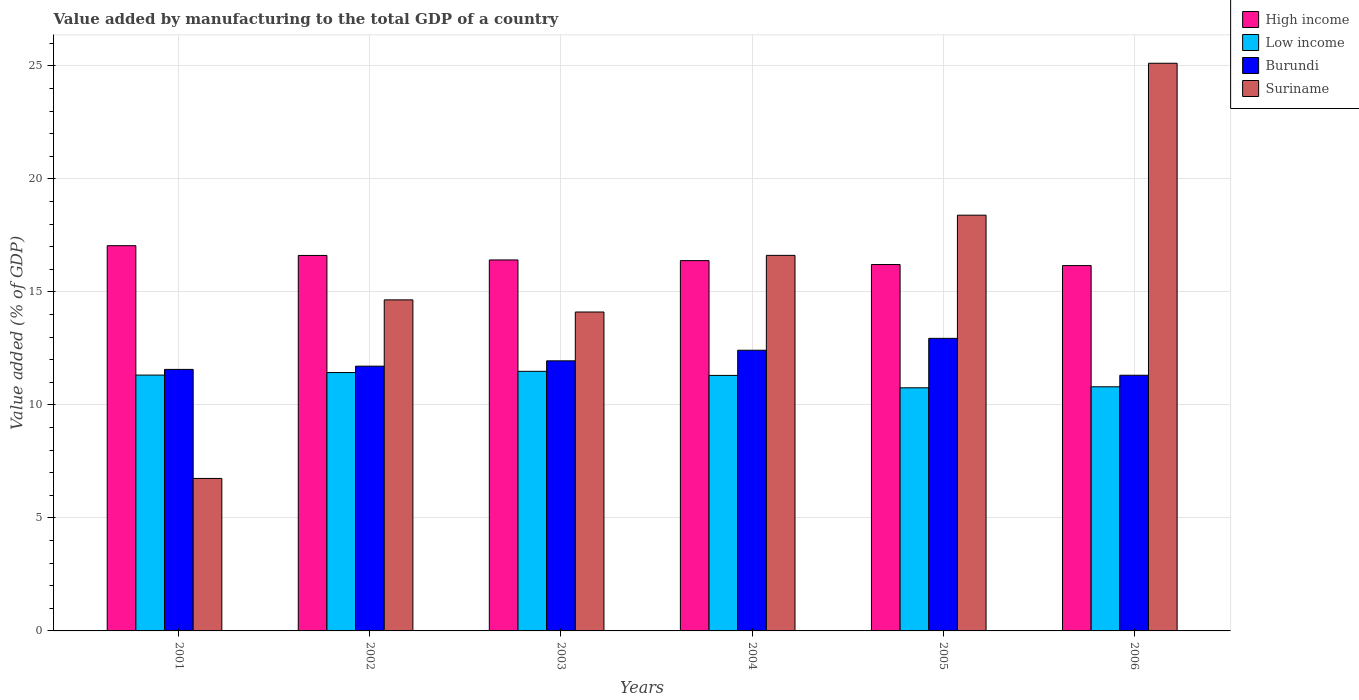Are the number of bars per tick equal to the number of legend labels?
Make the answer very short. Yes. How many bars are there on the 1st tick from the left?
Provide a succinct answer. 4. What is the label of the 5th group of bars from the left?
Provide a short and direct response. 2005. In how many cases, is the number of bars for a given year not equal to the number of legend labels?
Your response must be concise. 0. What is the value added by manufacturing to the total GDP in Suriname in 2005?
Provide a succinct answer. 18.39. Across all years, what is the maximum value added by manufacturing to the total GDP in Burundi?
Offer a terse response. 12.95. Across all years, what is the minimum value added by manufacturing to the total GDP in High income?
Provide a short and direct response. 16.16. What is the total value added by manufacturing to the total GDP in High income in the graph?
Make the answer very short. 98.83. What is the difference between the value added by manufacturing to the total GDP in High income in 2005 and that in 2006?
Make the answer very short. 0.05. What is the difference between the value added by manufacturing to the total GDP in Burundi in 2005 and the value added by manufacturing to the total GDP in Low income in 2004?
Give a very brief answer. 1.64. What is the average value added by manufacturing to the total GDP in Suriname per year?
Give a very brief answer. 15.94. In the year 2001, what is the difference between the value added by manufacturing to the total GDP in Suriname and value added by manufacturing to the total GDP in High income?
Your answer should be compact. -10.3. In how many years, is the value added by manufacturing to the total GDP in Low income greater than 14 %?
Give a very brief answer. 0. What is the ratio of the value added by manufacturing to the total GDP in High income in 2002 to that in 2004?
Offer a terse response. 1.01. What is the difference between the highest and the second highest value added by manufacturing to the total GDP in High income?
Offer a very short reply. 0.43. What is the difference between the highest and the lowest value added by manufacturing to the total GDP in Burundi?
Offer a terse response. 1.63. Is it the case that in every year, the sum of the value added by manufacturing to the total GDP in Low income and value added by manufacturing to the total GDP in Suriname is greater than the sum of value added by manufacturing to the total GDP in High income and value added by manufacturing to the total GDP in Burundi?
Your response must be concise. No. What does the 3rd bar from the left in 2002 represents?
Make the answer very short. Burundi. What does the 2nd bar from the right in 2006 represents?
Your response must be concise. Burundi. Is it the case that in every year, the sum of the value added by manufacturing to the total GDP in High income and value added by manufacturing to the total GDP in Suriname is greater than the value added by manufacturing to the total GDP in Low income?
Your response must be concise. Yes. How many years are there in the graph?
Give a very brief answer. 6. What is the difference between two consecutive major ticks on the Y-axis?
Provide a short and direct response. 5. Does the graph contain any zero values?
Give a very brief answer. No. How many legend labels are there?
Make the answer very short. 4. What is the title of the graph?
Offer a terse response. Value added by manufacturing to the total GDP of a country. Does "Channel Islands" appear as one of the legend labels in the graph?
Give a very brief answer. No. What is the label or title of the X-axis?
Your answer should be compact. Years. What is the label or title of the Y-axis?
Your answer should be compact. Value added (% of GDP). What is the Value added (% of GDP) in High income in 2001?
Ensure brevity in your answer.  17.05. What is the Value added (% of GDP) in Low income in 2001?
Your response must be concise. 11.32. What is the Value added (% of GDP) of Burundi in 2001?
Offer a terse response. 11.57. What is the Value added (% of GDP) of Suriname in 2001?
Ensure brevity in your answer.  6.75. What is the Value added (% of GDP) in High income in 2002?
Give a very brief answer. 16.61. What is the Value added (% of GDP) of Low income in 2002?
Offer a very short reply. 11.43. What is the Value added (% of GDP) of Burundi in 2002?
Offer a very short reply. 11.71. What is the Value added (% of GDP) of Suriname in 2002?
Your answer should be very brief. 14.65. What is the Value added (% of GDP) in High income in 2003?
Make the answer very short. 16.41. What is the Value added (% of GDP) of Low income in 2003?
Make the answer very short. 11.49. What is the Value added (% of GDP) in Burundi in 2003?
Make the answer very short. 11.95. What is the Value added (% of GDP) of Suriname in 2003?
Keep it short and to the point. 14.11. What is the Value added (% of GDP) in High income in 2004?
Keep it short and to the point. 16.38. What is the Value added (% of GDP) of Low income in 2004?
Your answer should be very brief. 11.3. What is the Value added (% of GDP) of Burundi in 2004?
Your answer should be very brief. 12.42. What is the Value added (% of GDP) of Suriname in 2004?
Provide a succinct answer. 16.62. What is the Value added (% of GDP) of High income in 2005?
Provide a succinct answer. 16.21. What is the Value added (% of GDP) of Low income in 2005?
Your response must be concise. 10.76. What is the Value added (% of GDP) in Burundi in 2005?
Your response must be concise. 12.95. What is the Value added (% of GDP) in Suriname in 2005?
Offer a terse response. 18.39. What is the Value added (% of GDP) of High income in 2006?
Provide a short and direct response. 16.16. What is the Value added (% of GDP) of Low income in 2006?
Give a very brief answer. 10.8. What is the Value added (% of GDP) in Burundi in 2006?
Keep it short and to the point. 11.31. What is the Value added (% of GDP) of Suriname in 2006?
Your response must be concise. 25.12. Across all years, what is the maximum Value added (% of GDP) in High income?
Offer a very short reply. 17.05. Across all years, what is the maximum Value added (% of GDP) of Low income?
Your answer should be compact. 11.49. Across all years, what is the maximum Value added (% of GDP) of Burundi?
Offer a very short reply. 12.95. Across all years, what is the maximum Value added (% of GDP) of Suriname?
Offer a very short reply. 25.12. Across all years, what is the minimum Value added (% of GDP) of High income?
Your answer should be compact. 16.16. Across all years, what is the minimum Value added (% of GDP) in Low income?
Offer a very short reply. 10.76. Across all years, what is the minimum Value added (% of GDP) of Burundi?
Make the answer very short. 11.31. Across all years, what is the minimum Value added (% of GDP) in Suriname?
Your answer should be very brief. 6.75. What is the total Value added (% of GDP) in High income in the graph?
Keep it short and to the point. 98.83. What is the total Value added (% of GDP) in Low income in the graph?
Provide a succinct answer. 67.1. What is the total Value added (% of GDP) in Burundi in the graph?
Make the answer very short. 71.91. What is the total Value added (% of GDP) in Suriname in the graph?
Keep it short and to the point. 95.63. What is the difference between the Value added (% of GDP) in High income in 2001 and that in 2002?
Ensure brevity in your answer.  0.43. What is the difference between the Value added (% of GDP) in Low income in 2001 and that in 2002?
Give a very brief answer. -0.11. What is the difference between the Value added (% of GDP) in Burundi in 2001 and that in 2002?
Make the answer very short. -0.14. What is the difference between the Value added (% of GDP) of Suriname in 2001 and that in 2002?
Your response must be concise. -7.9. What is the difference between the Value added (% of GDP) of High income in 2001 and that in 2003?
Your answer should be compact. 0.63. What is the difference between the Value added (% of GDP) in Low income in 2001 and that in 2003?
Your response must be concise. -0.17. What is the difference between the Value added (% of GDP) in Burundi in 2001 and that in 2003?
Keep it short and to the point. -0.38. What is the difference between the Value added (% of GDP) in Suriname in 2001 and that in 2003?
Offer a very short reply. -7.36. What is the difference between the Value added (% of GDP) of High income in 2001 and that in 2004?
Your answer should be very brief. 0.66. What is the difference between the Value added (% of GDP) of Low income in 2001 and that in 2004?
Your answer should be very brief. 0.01. What is the difference between the Value added (% of GDP) in Burundi in 2001 and that in 2004?
Your answer should be very brief. -0.85. What is the difference between the Value added (% of GDP) of Suriname in 2001 and that in 2004?
Your answer should be very brief. -9.87. What is the difference between the Value added (% of GDP) of High income in 2001 and that in 2005?
Keep it short and to the point. 0.83. What is the difference between the Value added (% of GDP) in Low income in 2001 and that in 2005?
Give a very brief answer. 0.56. What is the difference between the Value added (% of GDP) in Burundi in 2001 and that in 2005?
Your answer should be compact. -1.37. What is the difference between the Value added (% of GDP) in Suriname in 2001 and that in 2005?
Provide a succinct answer. -11.65. What is the difference between the Value added (% of GDP) in High income in 2001 and that in 2006?
Provide a succinct answer. 0.88. What is the difference between the Value added (% of GDP) in Low income in 2001 and that in 2006?
Keep it short and to the point. 0.52. What is the difference between the Value added (% of GDP) in Burundi in 2001 and that in 2006?
Ensure brevity in your answer.  0.26. What is the difference between the Value added (% of GDP) of Suriname in 2001 and that in 2006?
Your answer should be compact. -18.37. What is the difference between the Value added (% of GDP) of High income in 2002 and that in 2003?
Your answer should be compact. 0.2. What is the difference between the Value added (% of GDP) in Low income in 2002 and that in 2003?
Make the answer very short. -0.05. What is the difference between the Value added (% of GDP) of Burundi in 2002 and that in 2003?
Ensure brevity in your answer.  -0.24. What is the difference between the Value added (% of GDP) of Suriname in 2002 and that in 2003?
Your response must be concise. 0.54. What is the difference between the Value added (% of GDP) of High income in 2002 and that in 2004?
Make the answer very short. 0.23. What is the difference between the Value added (% of GDP) in Low income in 2002 and that in 2004?
Make the answer very short. 0.13. What is the difference between the Value added (% of GDP) in Burundi in 2002 and that in 2004?
Give a very brief answer. -0.7. What is the difference between the Value added (% of GDP) of Suriname in 2002 and that in 2004?
Provide a short and direct response. -1.97. What is the difference between the Value added (% of GDP) in High income in 2002 and that in 2005?
Make the answer very short. 0.4. What is the difference between the Value added (% of GDP) of Low income in 2002 and that in 2005?
Keep it short and to the point. 0.68. What is the difference between the Value added (% of GDP) of Burundi in 2002 and that in 2005?
Your answer should be compact. -1.23. What is the difference between the Value added (% of GDP) in Suriname in 2002 and that in 2005?
Keep it short and to the point. -3.75. What is the difference between the Value added (% of GDP) in High income in 2002 and that in 2006?
Give a very brief answer. 0.45. What is the difference between the Value added (% of GDP) in Low income in 2002 and that in 2006?
Keep it short and to the point. 0.63. What is the difference between the Value added (% of GDP) in Burundi in 2002 and that in 2006?
Your answer should be compact. 0.4. What is the difference between the Value added (% of GDP) of Suriname in 2002 and that in 2006?
Your answer should be very brief. -10.47. What is the difference between the Value added (% of GDP) of High income in 2003 and that in 2004?
Give a very brief answer. 0.03. What is the difference between the Value added (% of GDP) of Low income in 2003 and that in 2004?
Your response must be concise. 0.18. What is the difference between the Value added (% of GDP) of Burundi in 2003 and that in 2004?
Keep it short and to the point. -0.47. What is the difference between the Value added (% of GDP) in Suriname in 2003 and that in 2004?
Keep it short and to the point. -2.51. What is the difference between the Value added (% of GDP) in High income in 2003 and that in 2005?
Keep it short and to the point. 0.2. What is the difference between the Value added (% of GDP) in Low income in 2003 and that in 2005?
Offer a very short reply. 0.73. What is the difference between the Value added (% of GDP) in Burundi in 2003 and that in 2005?
Provide a succinct answer. -0.99. What is the difference between the Value added (% of GDP) of Suriname in 2003 and that in 2005?
Your answer should be compact. -4.28. What is the difference between the Value added (% of GDP) of High income in 2003 and that in 2006?
Provide a succinct answer. 0.25. What is the difference between the Value added (% of GDP) in Low income in 2003 and that in 2006?
Provide a short and direct response. 0.68. What is the difference between the Value added (% of GDP) of Burundi in 2003 and that in 2006?
Provide a short and direct response. 0.64. What is the difference between the Value added (% of GDP) in Suriname in 2003 and that in 2006?
Your answer should be very brief. -11.01. What is the difference between the Value added (% of GDP) in High income in 2004 and that in 2005?
Provide a short and direct response. 0.17. What is the difference between the Value added (% of GDP) in Low income in 2004 and that in 2005?
Your answer should be compact. 0.55. What is the difference between the Value added (% of GDP) in Burundi in 2004 and that in 2005?
Keep it short and to the point. -0.53. What is the difference between the Value added (% of GDP) of Suriname in 2004 and that in 2005?
Your answer should be very brief. -1.78. What is the difference between the Value added (% of GDP) of High income in 2004 and that in 2006?
Provide a succinct answer. 0.22. What is the difference between the Value added (% of GDP) in Low income in 2004 and that in 2006?
Offer a terse response. 0.5. What is the difference between the Value added (% of GDP) in Burundi in 2004 and that in 2006?
Make the answer very short. 1.11. What is the difference between the Value added (% of GDP) in Suriname in 2004 and that in 2006?
Make the answer very short. -8.5. What is the difference between the Value added (% of GDP) in High income in 2005 and that in 2006?
Make the answer very short. 0.05. What is the difference between the Value added (% of GDP) in Low income in 2005 and that in 2006?
Offer a very short reply. -0.04. What is the difference between the Value added (% of GDP) in Burundi in 2005 and that in 2006?
Offer a very short reply. 1.63. What is the difference between the Value added (% of GDP) of Suriname in 2005 and that in 2006?
Offer a very short reply. -6.72. What is the difference between the Value added (% of GDP) in High income in 2001 and the Value added (% of GDP) in Low income in 2002?
Keep it short and to the point. 5.61. What is the difference between the Value added (% of GDP) in High income in 2001 and the Value added (% of GDP) in Burundi in 2002?
Your answer should be very brief. 5.33. What is the difference between the Value added (% of GDP) of High income in 2001 and the Value added (% of GDP) of Suriname in 2002?
Offer a terse response. 2.4. What is the difference between the Value added (% of GDP) of Low income in 2001 and the Value added (% of GDP) of Burundi in 2002?
Provide a succinct answer. -0.39. What is the difference between the Value added (% of GDP) of Low income in 2001 and the Value added (% of GDP) of Suriname in 2002?
Your answer should be compact. -3.33. What is the difference between the Value added (% of GDP) in Burundi in 2001 and the Value added (% of GDP) in Suriname in 2002?
Provide a short and direct response. -3.08. What is the difference between the Value added (% of GDP) of High income in 2001 and the Value added (% of GDP) of Low income in 2003?
Provide a succinct answer. 5.56. What is the difference between the Value added (% of GDP) of High income in 2001 and the Value added (% of GDP) of Burundi in 2003?
Offer a very short reply. 5.1. What is the difference between the Value added (% of GDP) of High income in 2001 and the Value added (% of GDP) of Suriname in 2003?
Ensure brevity in your answer.  2.93. What is the difference between the Value added (% of GDP) of Low income in 2001 and the Value added (% of GDP) of Burundi in 2003?
Offer a very short reply. -0.63. What is the difference between the Value added (% of GDP) of Low income in 2001 and the Value added (% of GDP) of Suriname in 2003?
Ensure brevity in your answer.  -2.79. What is the difference between the Value added (% of GDP) in Burundi in 2001 and the Value added (% of GDP) in Suriname in 2003?
Give a very brief answer. -2.54. What is the difference between the Value added (% of GDP) of High income in 2001 and the Value added (% of GDP) of Low income in 2004?
Make the answer very short. 5.74. What is the difference between the Value added (% of GDP) in High income in 2001 and the Value added (% of GDP) in Burundi in 2004?
Keep it short and to the point. 4.63. What is the difference between the Value added (% of GDP) in High income in 2001 and the Value added (% of GDP) in Suriname in 2004?
Your answer should be compact. 0.43. What is the difference between the Value added (% of GDP) in Low income in 2001 and the Value added (% of GDP) in Burundi in 2004?
Offer a very short reply. -1.1. What is the difference between the Value added (% of GDP) of Low income in 2001 and the Value added (% of GDP) of Suriname in 2004?
Your answer should be compact. -5.3. What is the difference between the Value added (% of GDP) of Burundi in 2001 and the Value added (% of GDP) of Suriname in 2004?
Offer a very short reply. -5.05. What is the difference between the Value added (% of GDP) of High income in 2001 and the Value added (% of GDP) of Low income in 2005?
Your response must be concise. 6.29. What is the difference between the Value added (% of GDP) in High income in 2001 and the Value added (% of GDP) in Burundi in 2005?
Offer a very short reply. 4.1. What is the difference between the Value added (% of GDP) in High income in 2001 and the Value added (% of GDP) in Suriname in 2005?
Your answer should be compact. -1.35. What is the difference between the Value added (% of GDP) of Low income in 2001 and the Value added (% of GDP) of Burundi in 2005?
Your answer should be compact. -1.63. What is the difference between the Value added (% of GDP) of Low income in 2001 and the Value added (% of GDP) of Suriname in 2005?
Offer a very short reply. -7.07. What is the difference between the Value added (% of GDP) of Burundi in 2001 and the Value added (% of GDP) of Suriname in 2005?
Provide a succinct answer. -6.82. What is the difference between the Value added (% of GDP) of High income in 2001 and the Value added (% of GDP) of Low income in 2006?
Your response must be concise. 6.24. What is the difference between the Value added (% of GDP) of High income in 2001 and the Value added (% of GDP) of Burundi in 2006?
Make the answer very short. 5.73. What is the difference between the Value added (% of GDP) of High income in 2001 and the Value added (% of GDP) of Suriname in 2006?
Your answer should be compact. -8.07. What is the difference between the Value added (% of GDP) in Low income in 2001 and the Value added (% of GDP) in Burundi in 2006?
Your response must be concise. 0.01. What is the difference between the Value added (% of GDP) in Low income in 2001 and the Value added (% of GDP) in Suriname in 2006?
Keep it short and to the point. -13.8. What is the difference between the Value added (% of GDP) of Burundi in 2001 and the Value added (% of GDP) of Suriname in 2006?
Ensure brevity in your answer.  -13.55. What is the difference between the Value added (% of GDP) in High income in 2002 and the Value added (% of GDP) in Low income in 2003?
Ensure brevity in your answer.  5.13. What is the difference between the Value added (% of GDP) of High income in 2002 and the Value added (% of GDP) of Burundi in 2003?
Provide a succinct answer. 4.66. What is the difference between the Value added (% of GDP) in High income in 2002 and the Value added (% of GDP) in Suriname in 2003?
Offer a very short reply. 2.5. What is the difference between the Value added (% of GDP) in Low income in 2002 and the Value added (% of GDP) in Burundi in 2003?
Your answer should be very brief. -0.52. What is the difference between the Value added (% of GDP) in Low income in 2002 and the Value added (% of GDP) in Suriname in 2003?
Provide a short and direct response. -2.68. What is the difference between the Value added (% of GDP) in Burundi in 2002 and the Value added (% of GDP) in Suriname in 2003?
Provide a short and direct response. -2.4. What is the difference between the Value added (% of GDP) in High income in 2002 and the Value added (% of GDP) in Low income in 2004?
Ensure brevity in your answer.  5.31. What is the difference between the Value added (% of GDP) in High income in 2002 and the Value added (% of GDP) in Burundi in 2004?
Give a very brief answer. 4.19. What is the difference between the Value added (% of GDP) in High income in 2002 and the Value added (% of GDP) in Suriname in 2004?
Provide a succinct answer. -0. What is the difference between the Value added (% of GDP) of Low income in 2002 and the Value added (% of GDP) of Burundi in 2004?
Your response must be concise. -0.99. What is the difference between the Value added (% of GDP) in Low income in 2002 and the Value added (% of GDP) in Suriname in 2004?
Provide a succinct answer. -5.18. What is the difference between the Value added (% of GDP) of Burundi in 2002 and the Value added (% of GDP) of Suriname in 2004?
Give a very brief answer. -4.9. What is the difference between the Value added (% of GDP) of High income in 2002 and the Value added (% of GDP) of Low income in 2005?
Provide a short and direct response. 5.86. What is the difference between the Value added (% of GDP) in High income in 2002 and the Value added (% of GDP) in Burundi in 2005?
Your answer should be compact. 3.67. What is the difference between the Value added (% of GDP) in High income in 2002 and the Value added (% of GDP) in Suriname in 2005?
Offer a very short reply. -1.78. What is the difference between the Value added (% of GDP) of Low income in 2002 and the Value added (% of GDP) of Burundi in 2005?
Make the answer very short. -1.51. What is the difference between the Value added (% of GDP) in Low income in 2002 and the Value added (% of GDP) in Suriname in 2005?
Offer a terse response. -6.96. What is the difference between the Value added (% of GDP) in Burundi in 2002 and the Value added (% of GDP) in Suriname in 2005?
Give a very brief answer. -6.68. What is the difference between the Value added (% of GDP) of High income in 2002 and the Value added (% of GDP) of Low income in 2006?
Make the answer very short. 5.81. What is the difference between the Value added (% of GDP) of High income in 2002 and the Value added (% of GDP) of Burundi in 2006?
Provide a succinct answer. 5.3. What is the difference between the Value added (% of GDP) of High income in 2002 and the Value added (% of GDP) of Suriname in 2006?
Ensure brevity in your answer.  -8.5. What is the difference between the Value added (% of GDP) in Low income in 2002 and the Value added (% of GDP) in Burundi in 2006?
Make the answer very short. 0.12. What is the difference between the Value added (% of GDP) in Low income in 2002 and the Value added (% of GDP) in Suriname in 2006?
Keep it short and to the point. -13.68. What is the difference between the Value added (% of GDP) in Burundi in 2002 and the Value added (% of GDP) in Suriname in 2006?
Your response must be concise. -13.4. What is the difference between the Value added (% of GDP) of High income in 2003 and the Value added (% of GDP) of Low income in 2004?
Keep it short and to the point. 5.11. What is the difference between the Value added (% of GDP) in High income in 2003 and the Value added (% of GDP) in Burundi in 2004?
Offer a very short reply. 3.99. What is the difference between the Value added (% of GDP) of High income in 2003 and the Value added (% of GDP) of Suriname in 2004?
Ensure brevity in your answer.  -0.2. What is the difference between the Value added (% of GDP) in Low income in 2003 and the Value added (% of GDP) in Burundi in 2004?
Provide a succinct answer. -0.93. What is the difference between the Value added (% of GDP) of Low income in 2003 and the Value added (% of GDP) of Suriname in 2004?
Keep it short and to the point. -5.13. What is the difference between the Value added (% of GDP) in Burundi in 2003 and the Value added (% of GDP) in Suriname in 2004?
Your response must be concise. -4.67. What is the difference between the Value added (% of GDP) of High income in 2003 and the Value added (% of GDP) of Low income in 2005?
Make the answer very short. 5.66. What is the difference between the Value added (% of GDP) in High income in 2003 and the Value added (% of GDP) in Burundi in 2005?
Ensure brevity in your answer.  3.47. What is the difference between the Value added (% of GDP) in High income in 2003 and the Value added (% of GDP) in Suriname in 2005?
Make the answer very short. -1.98. What is the difference between the Value added (% of GDP) in Low income in 2003 and the Value added (% of GDP) in Burundi in 2005?
Your response must be concise. -1.46. What is the difference between the Value added (% of GDP) of Low income in 2003 and the Value added (% of GDP) of Suriname in 2005?
Offer a very short reply. -6.91. What is the difference between the Value added (% of GDP) of Burundi in 2003 and the Value added (% of GDP) of Suriname in 2005?
Keep it short and to the point. -6.44. What is the difference between the Value added (% of GDP) in High income in 2003 and the Value added (% of GDP) in Low income in 2006?
Your answer should be very brief. 5.61. What is the difference between the Value added (% of GDP) of High income in 2003 and the Value added (% of GDP) of Burundi in 2006?
Ensure brevity in your answer.  5.1. What is the difference between the Value added (% of GDP) in High income in 2003 and the Value added (% of GDP) in Suriname in 2006?
Keep it short and to the point. -8.7. What is the difference between the Value added (% of GDP) of Low income in 2003 and the Value added (% of GDP) of Burundi in 2006?
Your answer should be compact. 0.17. What is the difference between the Value added (% of GDP) of Low income in 2003 and the Value added (% of GDP) of Suriname in 2006?
Provide a succinct answer. -13.63. What is the difference between the Value added (% of GDP) in Burundi in 2003 and the Value added (% of GDP) in Suriname in 2006?
Your response must be concise. -13.17. What is the difference between the Value added (% of GDP) in High income in 2004 and the Value added (% of GDP) in Low income in 2005?
Offer a terse response. 5.63. What is the difference between the Value added (% of GDP) in High income in 2004 and the Value added (% of GDP) in Burundi in 2005?
Provide a succinct answer. 3.44. What is the difference between the Value added (% of GDP) in High income in 2004 and the Value added (% of GDP) in Suriname in 2005?
Provide a short and direct response. -2.01. What is the difference between the Value added (% of GDP) of Low income in 2004 and the Value added (% of GDP) of Burundi in 2005?
Offer a very short reply. -1.64. What is the difference between the Value added (% of GDP) in Low income in 2004 and the Value added (% of GDP) in Suriname in 2005?
Keep it short and to the point. -7.09. What is the difference between the Value added (% of GDP) in Burundi in 2004 and the Value added (% of GDP) in Suriname in 2005?
Provide a short and direct response. -5.98. What is the difference between the Value added (% of GDP) in High income in 2004 and the Value added (% of GDP) in Low income in 2006?
Offer a very short reply. 5.58. What is the difference between the Value added (% of GDP) in High income in 2004 and the Value added (% of GDP) in Burundi in 2006?
Provide a short and direct response. 5.07. What is the difference between the Value added (% of GDP) in High income in 2004 and the Value added (% of GDP) in Suriname in 2006?
Your answer should be very brief. -8.73. What is the difference between the Value added (% of GDP) in Low income in 2004 and the Value added (% of GDP) in Burundi in 2006?
Give a very brief answer. -0.01. What is the difference between the Value added (% of GDP) in Low income in 2004 and the Value added (% of GDP) in Suriname in 2006?
Your response must be concise. -13.81. What is the difference between the Value added (% of GDP) in Burundi in 2004 and the Value added (% of GDP) in Suriname in 2006?
Provide a succinct answer. -12.7. What is the difference between the Value added (% of GDP) in High income in 2005 and the Value added (% of GDP) in Low income in 2006?
Make the answer very short. 5.41. What is the difference between the Value added (% of GDP) in High income in 2005 and the Value added (% of GDP) in Burundi in 2006?
Provide a short and direct response. 4.9. What is the difference between the Value added (% of GDP) of High income in 2005 and the Value added (% of GDP) of Suriname in 2006?
Offer a very short reply. -8.91. What is the difference between the Value added (% of GDP) in Low income in 2005 and the Value added (% of GDP) in Burundi in 2006?
Make the answer very short. -0.56. What is the difference between the Value added (% of GDP) in Low income in 2005 and the Value added (% of GDP) in Suriname in 2006?
Make the answer very short. -14.36. What is the difference between the Value added (% of GDP) in Burundi in 2005 and the Value added (% of GDP) in Suriname in 2006?
Provide a short and direct response. -12.17. What is the average Value added (% of GDP) in High income per year?
Make the answer very short. 16.47. What is the average Value added (% of GDP) in Low income per year?
Provide a short and direct response. 11.18. What is the average Value added (% of GDP) in Burundi per year?
Keep it short and to the point. 11.99. What is the average Value added (% of GDP) of Suriname per year?
Offer a terse response. 15.94. In the year 2001, what is the difference between the Value added (% of GDP) in High income and Value added (% of GDP) in Low income?
Provide a succinct answer. 5.73. In the year 2001, what is the difference between the Value added (% of GDP) of High income and Value added (% of GDP) of Burundi?
Your answer should be compact. 5.47. In the year 2001, what is the difference between the Value added (% of GDP) of High income and Value added (% of GDP) of Suriname?
Make the answer very short. 10.3. In the year 2001, what is the difference between the Value added (% of GDP) of Low income and Value added (% of GDP) of Burundi?
Your response must be concise. -0.25. In the year 2001, what is the difference between the Value added (% of GDP) of Low income and Value added (% of GDP) of Suriname?
Provide a succinct answer. 4.57. In the year 2001, what is the difference between the Value added (% of GDP) of Burundi and Value added (% of GDP) of Suriname?
Make the answer very short. 4.82. In the year 2002, what is the difference between the Value added (% of GDP) of High income and Value added (% of GDP) of Low income?
Keep it short and to the point. 5.18. In the year 2002, what is the difference between the Value added (% of GDP) of High income and Value added (% of GDP) of Burundi?
Provide a short and direct response. 4.9. In the year 2002, what is the difference between the Value added (% of GDP) of High income and Value added (% of GDP) of Suriname?
Your answer should be compact. 1.97. In the year 2002, what is the difference between the Value added (% of GDP) in Low income and Value added (% of GDP) in Burundi?
Your response must be concise. -0.28. In the year 2002, what is the difference between the Value added (% of GDP) in Low income and Value added (% of GDP) in Suriname?
Give a very brief answer. -3.22. In the year 2002, what is the difference between the Value added (% of GDP) in Burundi and Value added (% of GDP) in Suriname?
Your answer should be compact. -2.93. In the year 2003, what is the difference between the Value added (% of GDP) in High income and Value added (% of GDP) in Low income?
Make the answer very short. 4.93. In the year 2003, what is the difference between the Value added (% of GDP) in High income and Value added (% of GDP) in Burundi?
Offer a very short reply. 4.46. In the year 2003, what is the difference between the Value added (% of GDP) in High income and Value added (% of GDP) in Suriname?
Your answer should be very brief. 2.3. In the year 2003, what is the difference between the Value added (% of GDP) of Low income and Value added (% of GDP) of Burundi?
Provide a succinct answer. -0.46. In the year 2003, what is the difference between the Value added (% of GDP) in Low income and Value added (% of GDP) in Suriname?
Your answer should be very brief. -2.62. In the year 2003, what is the difference between the Value added (% of GDP) in Burundi and Value added (% of GDP) in Suriname?
Your response must be concise. -2.16. In the year 2004, what is the difference between the Value added (% of GDP) in High income and Value added (% of GDP) in Low income?
Provide a succinct answer. 5.08. In the year 2004, what is the difference between the Value added (% of GDP) of High income and Value added (% of GDP) of Burundi?
Ensure brevity in your answer.  3.97. In the year 2004, what is the difference between the Value added (% of GDP) in High income and Value added (% of GDP) in Suriname?
Your answer should be compact. -0.23. In the year 2004, what is the difference between the Value added (% of GDP) in Low income and Value added (% of GDP) in Burundi?
Offer a very short reply. -1.11. In the year 2004, what is the difference between the Value added (% of GDP) of Low income and Value added (% of GDP) of Suriname?
Provide a short and direct response. -5.31. In the year 2004, what is the difference between the Value added (% of GDP) in Burundi and Value added (% of GDP) in Suriname?
Your response must be concise. -4.2. In the year 2005, what is the difference between the Value added (% of GDP) in High income and Value added (% of GDP) in Low income?
Provide a short and direct response. 5.45. In the year 2005, what is the difference between the Value added (% of GDP) in High income and Value added (% of GDP) in Burundi?
Your answer should be very brief. 3.27. In the year 2005, what is the difference between the Value added (% of GDP) of High income and Value added (% of GDP) of Suriname?
Offer a terse response. -2.18. In the year 2005, what is the difference between the Value added (% of GDP) of Low income and Value added (% of GDP) of Burundi?
Offer a very short reply. -2.19. In the year 2005, what is the difference between the Value added (% of GDP) in Low income and Value added (% of GDP) in Suriname?
Your answer should be very brief. -7.64. In the year 2005, what is the difference between the Value added (% of GDP) in Burundi and Value added (% of GDP) in Suriname?
Provide a short and direct response. -5.45. In the year 2006, what is the difference between the Value added (% of GDP) of High income and Value added (% of GDP) of Low income?
Provide a short and direct response. 5.36. In the year 2006, what is the difference between the Value added (% of GDP) of High income and Value added (% of GDP) of Burundi?
Provide a short and direct response. 4.85. In the year 2006, what is the difference between the Value added (% of GDP) in High income and Value added (% of GDP) in Suriname?
Your answer should be compact. -8.95. In the year 2006, what is the difference between the Value added (% of GDP) of Low income and Value added (% of GDP) of Burundi?
Ensure brevity in your answer.  -0.51. In the year 2006, what is the difference between the Value added (% of GDP) of Low income and Value added (% of GDP) of Suriname?
Make the answer very short. -14.31. In the year 2006, what is the difference between the Value added (% of GDP) of Burundi and Value added (% of GDP) of Suriname?
Offer a terse response. -13.8. What is the ratio of the Value added (% of GDP) of High income in 2001 to that in 2002?
Make the answer very short. 1.03. What is the ratio of the Value added (% of GDP) in Low income in 2001 to that in 2002?
Your answer should be very brief. 0.99. What is the ratio of the Value added (% of GDP) of Burundi in 2001 to that in 2002?
Offer a terse response. 0.99. What is the ratio of the Value added (% of GDP) of Suriname in 2001 to that in 2002?
Give a very brief answer. 0.46. What is the ratio of the Value added (% of GDP) in High income in 2001 to that in 2003?
Ensure brevity in your answer.  1.04. What is the ratio of the Value added (% of GDP) in Low income in 2001 to that in 2003?
Provide a succinct answer. 0.99. What is the ratio of the Value added (% of GDP) of Burundi in 2001 to that in 2003?
Your response must be concise. 0.97. What is the ratio of the Value added (% of GDP) of Suriname in 2001 to that in 2003?
Make the answer very short. 0.48. What is the ratio of the Value added (% of GDP) in High income in 2001 to that in 2004?
Keep it short and to the point. 1.04. What is the ratio of the Value added (% of GDP) of Burundi in 2001 to that in 2004?
Offer a terse response. 0.93. What is the ratio of the Value added (% of GDP) in Suriname in 2001 to that in 2004?
Offer a very short reply. 0.41. What is the ratio of the Value added (% of GDP) in High income in 2001 to that in 2005?
Your response must be concise. 1.05. What is the ratio of the Value added (% of GDP) of Low income in 2001 to that in 2005?
Provide a short and direct response. 1.05. What is the ratio of the Value added (% of GDP) of Burundi in 2001 to that in 2005?
Your response must be concise. 0.89. What is the ratio of the Value added (% of GDP) in Suriname in 2001 to that in 2005?
Offer a terse response. 0.37. What is the ratio of the Value added (% of GDP) of High income in 2001 to that in 2006?
Keep it short and to the point. 1.05. What is the ratio of the Value added (% of GDP) of Low income in 2001 to that in 2006?
Your answer should be compact. 1.05. What is the ratio of the Value added (% of GDP) of Burundi in 2001 to that in 2006?
Offer a very short reply. 1.02. What is the ratio of the Value added (% of GDP) in Suriname in 2001 to that in 2006?
Your response must be concise. 0.27. What is the ratio of the Value added (% of GDP) of High income in 2002 to that in 2003?
Give a very brief answer. 1.01. What is the ratio of the Value added (% of GDP) of Low income in 2002 to that in 2003?
Ensure brevity in your answer.  1. What is the ratio of the Value added (% of GDP) in Burundi in 2002 to that in 2003?
Make the answer very short. 0.98. What is the ratio of the Value added (% of GDP) in Suriname in 2002 to that in 2003?
Provide a short and direct response. 1.04. What is the ratio of the Value added (% of GDP) of Low income in 2002 to that in 2004?
Provide a short and direct response. 1.01. What is the ratio of the Value added (% of GDP) of Burundi in 2002 to that in 2004?
Give a very brief answer. 0.94. What is the ratio of the Value added (% of GDP) of Suriname in 2002 to that in 2004?
Ensure brevity in your answer.  0.88. What is the ratio of the Value added (% of GDP) of High income in 2002 to that in 2005?
Ensure brevity in your answer.  1.02. What is the ratio of the Value added (% of GDP) of Low income in 2002 to that in 2005?
Your response must be concise. 1.06. What is the ratio of the Value added (% of GDP) in Burundi in 2002 to that in 2005?
Offer a very short reply. 0.9. What is the ratio of the Value added (% of GDP) in Suriname in 2002 to that in 2005?
Make the answer very short. 0.8. What is the ratio of the Value added (% of GDP) in High income in 2002 to that in 2006?
Ensure brevity in your answer.  1.03. What is the ratio of the Value added (% of GDP) of Low income in 2002 to that in 2006?
Your response must be concise. 1.06. What is the ratio of the Value added (% of GDP) in Burundi in 2002 to that in 2006?
Make the answer very short. 1.04. What is the ratio of the Value added (% of GDP) in Suriname in 2002 to that in 2006?
Your answer should be very brief. 0.58. What is the ratio of the Value added (% of GDP) of High income in 2003 to that in 2004?
Give a very brief answer. 1. What is the ratio of the Value added (% of GDP) of Burundi in 2003 to that in 2004?
Give a very brief answer. 0.96. What is the ratio of the Value added (% of GDP) of Suriname in 2003 to that in 2004?
Keep it short and to the point. 0.85. What is the ratio of the Value added (% of GDP) in High income in 2003 to that in 2005?
Offer a very short reply. 1.01. What is the ratio of the Value added (% of GDP) in Low income in 2003 to that in 2005?
Your response must be concise. 1.07. What is the ratio of the Value added (% of GDP) in Suriname in 2003 to that in 2005?
Give a very brief answer. 0.77. What is the ratio of the Value added (% of GDP) of High income in 2003 to that in 2006?
Your response must be concise. 1.02. What is the ratio of the Value added (% of GDP) in Low income in 2003 to that in 2006?
Your answer should be very brief. 1.06. What is the ratio of the Value added (% of GDP) of Burundi in 2003 to that in 2006?
Offer a very short reply. 1.06. What is the ratio of the Value added (% of GDP) in Suriname in 2003 to that in 2006?
Your answer should be compact. 0.56. What is the ratio of the Value added (% of GDP) of High income in 2004 to that in 2005?
Give a very brief answer. 1.01. What is the ratio of the Value added (% of GDP) in Low income in 2004 to that in 2005?
Keep it short and to the point. 1.05. What is the ratio of the Value added (% of GDP) in Burundi in 2004 to that in 2005?
Keep it short and to the point. 0.96. What is the ratio of the Value added (% of GDP) of Suriname in 2004 to that in 2005?
Your response must be concise. 0.9. What is the ratio of the Value added (% of GDP) of High income in 2004 to that in 2006?
Your answer should be compact. 1.01. What is the ratio of the Value added (% of GDP) of Low income in 2004 to that in 2006?
Offer a terse response. 1.05. What is the ratio of the Value added (% of GDP) in Burundi in 2004 to that in 2006?
Give a very brief answer. 1.1. What is the ratio of the Value added (% of GDP) in Suriname in 2004 to that in 2006?
Your answer should be compact. 0.66. What is the ratio of the Value added (% of GDP) in High income in 2005 to that in 2006?
Make the answer very short. 1. What is the ratio of the Value added (% of GDP) of Low income in 2005 to that in 2006?
Your answer should be very brief. 1. What is the ratio of the Value added (% of GDP) of Burundi in 2005 to that in 2006?
Make the answer very short. 1.14. What is the ratio of the Value added (% of GDP) in Suriname in 2005 to that in 2006?
Your answer should be very brief. 0.73. What is the difference between the highest and the second highest Value added (% of GDP) of High income?
Your answer should be very brief. 0.43. What is the difference between the highest and the second highest Value added (% of GDP) in Low income?
Offer a terse response. 0.05. What is the difference between the highest and the second highest Value added (% of GDP) of Burundi?
Give a very brief answer. 0.53. What is the difference between the highest and the second highest Value added (% of GDP) of Suriname?
Your answer should be very brief. 6.72. What is the difference between the highest and the lowest Value added (% of GDP) of High income?
Make the answer very short. 0.88. What is the difference between the highest and the lowest Value added (% of GDP) of Low income?
Offer a very short reply. 0.73. What is the difference between the highest and the lowest Value added (% of GDP) of Burundi?
Keep it short and to the point. 1.63. What is the difference between the highest and the lowest Value added (% of GDP) in Suriname?
Offer a very short reply. 18.37. 